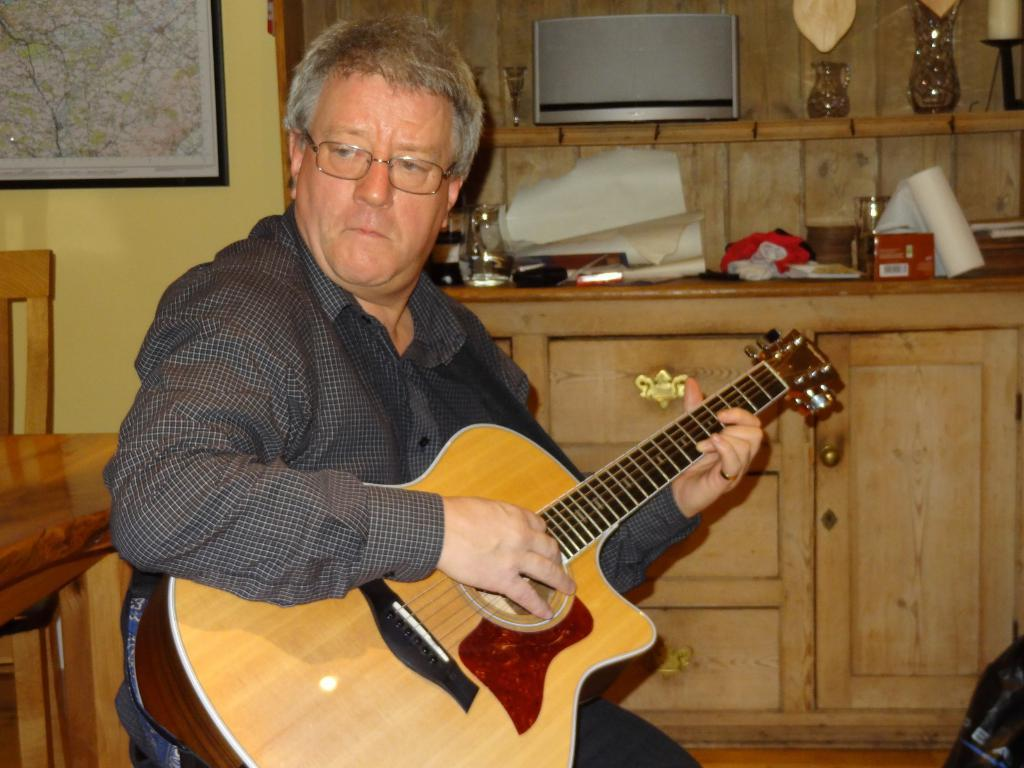What is the man in the image holding? The man is holding a guitar. What accessory is the man wearing in the image? The man is wearing glasses (specs). What can be seen on the wall in the background of the image? There is a map on a wall in the background of the image. What piece of furniture is visible in the background of the image? There is a chair in the background of the image. What type of battle is depicted on the guitar in the image? There is no battle depicted on the guitar in the image; it is a musical instrument. 